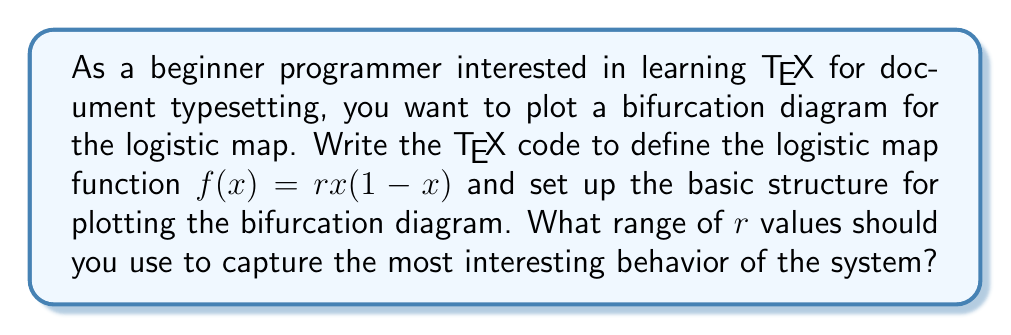Give your solution to this math problem. To answer this question, let's break it down into steps:

1. Define the logistic map function in TeX:
   $$f(x) = rx(1-x)$$

2. Set up the basic structure for plotting:
   \begin{tikzpicture}
   \begin{axis}[
     xlabel=$r$,
     ylabel=$x$,
     xmin=0, xmax=4,
     ymin=0, ymax=1
   ]
   % Plotting commands will go here
   \end{axis}
   \end{tikzpicture}

3. The range of $r$ values:
   The logistic map shows different behaviors for different values of $r$:
   - For $0 < r < 1$, the population will eventually die out.
   - For $1 < r < 3$, the population will quickly approach a steady state.
   - For $3 < r < 3.57$ (approximately), the population oscillates between two or more values.
   - For $r > 3.57$ (approximately), the system exhibits chaotic behavior.

4. To capture the most interesting behavior, including the period-doubling bifurcations and the onset of chaos, we should focus on the range:
   $$2.5 \leq r \leq 4$$

   This range allows us to observe:
   - The stable fixed point region
   - The period-doubling bifurcations
   - The chaotic regime
   - The periodic windows within the chaotic regime

5. In TeX, we would set this range in the axis options:
   xmin=2.5, xmax=4

By using this range, we ensure that we capture the rich dynamics of the logistic map, including the transition to chaos, which is crucial for a bifurcation diagram.
Answer: $2.5 \leq r \leq 4$ 